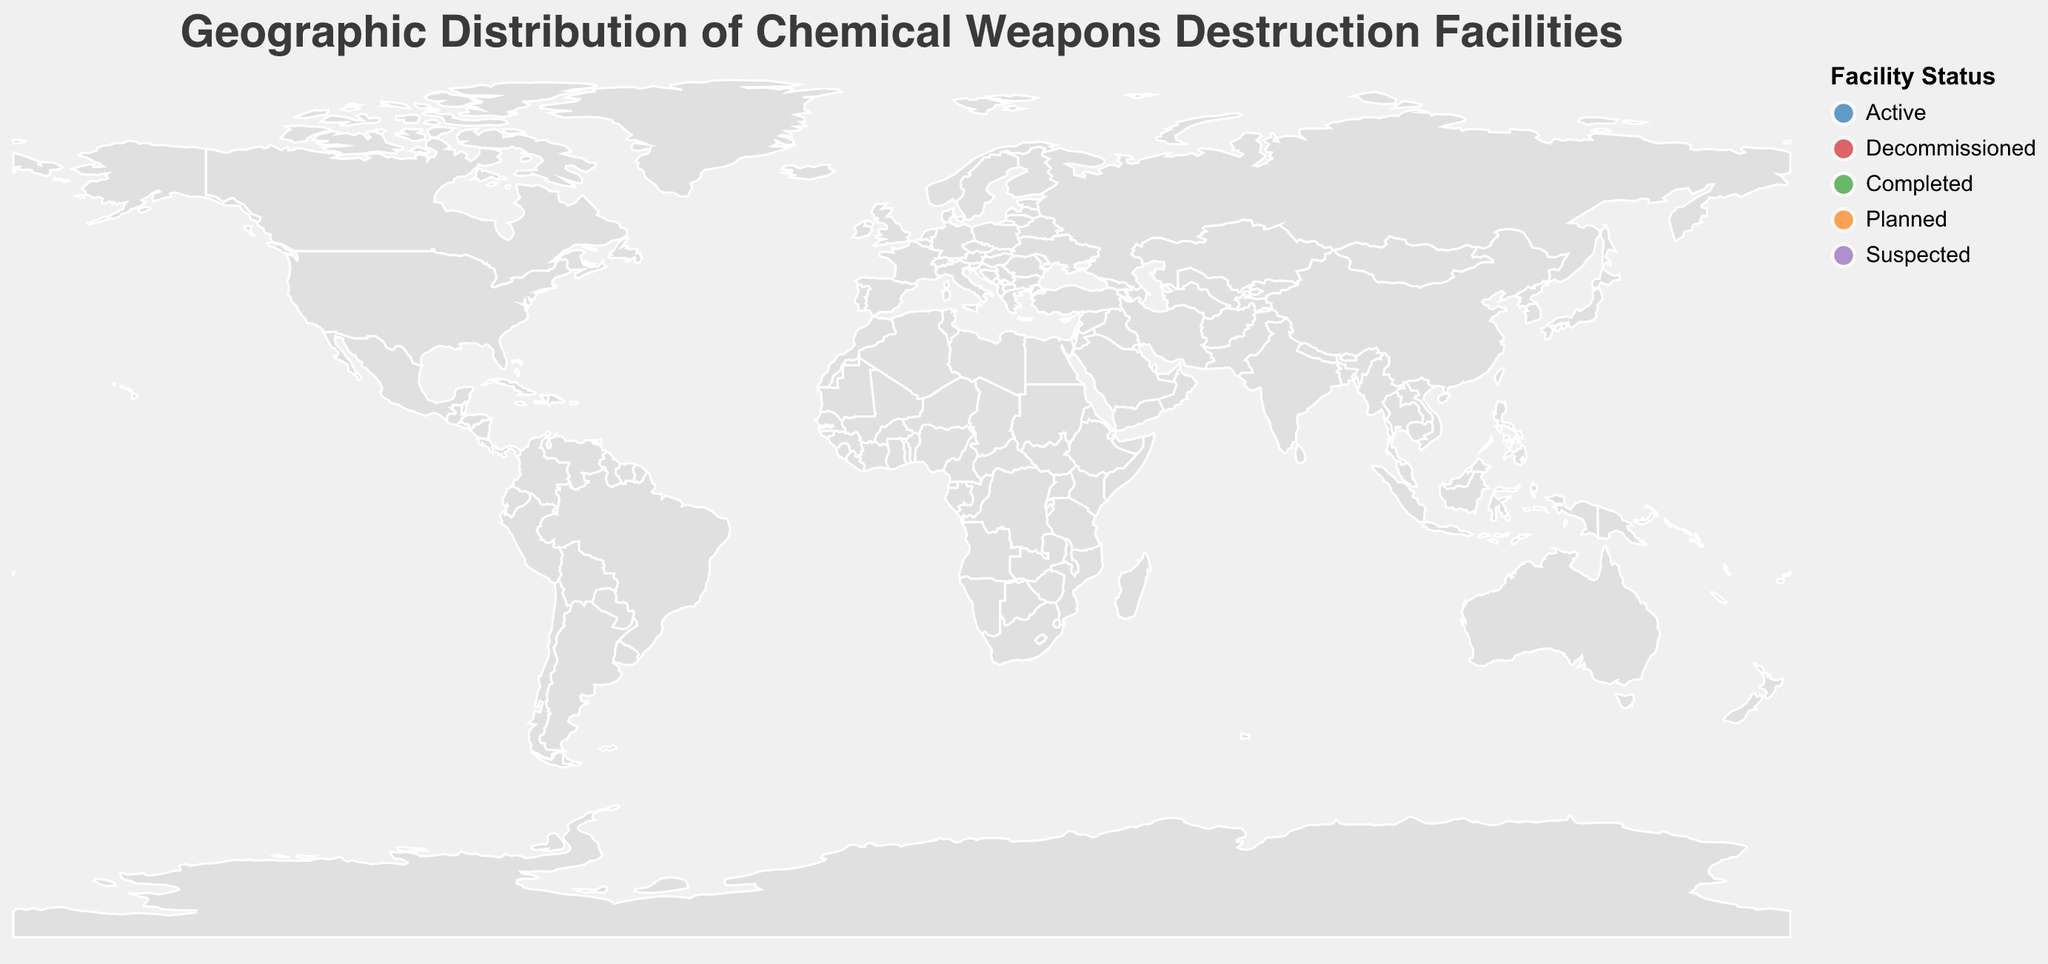Which country has the highest destruction capacity? The figure shows various destruction capacities for different facilities. Among all, the Shchuchye Chemical Weapons Destruction Facility in Russia has the highest capacity of 1100 units.
Answer: Russia How many facilities are listed as Active on the map? The figure uses different colors to denote the status of each facility. The "Active" status is marked in blue. We can count the blue circles and find that there are 3 active facilities: Blue Grass Chemical Agent-Destruction Pilot Plant, Hawthorne Army Depot, and Munster-Grohn GEKA Facility.
Answer: 3 What is the total destruction capacity of the facilities in the USA? There are three facilities in the USA: Blue Grass Chemical Agent-Destruction Pilot Plant with a capacity of 523, Anniston Chemical Agent Disposal Facility with 0, and Hawthorne Army Depot with a capacity of 45. Summing these capacities: 523 + 0 + 45 = 568.
Answer: 568 Which facility in the figure has the smallest destruction capacity and what is its status? The figure shows different destruction capacities represented by the size of the circles. The Dimona Facility in Israel has the smallest capacity of 18, and its status is "Suspected."
Answer: Dimona Facility, Suspected Compare the destruction capacities between the active facilities in Germany and Tunisia. Which one is higher and by how much? The Munster-Grohn GEKA Facility in Germany is active with a capacity of 36, while the Mornag Chemical Weapons Destruction Facility in Tunisia is planned with a capacity of 0. Thus, the German facility has a higher capacity by 36 units.
Answer: Germany by 36 Which continent shows the highest number of facilities, and how many are there? By visually scanning the geographic locations on the map, North America appears to have the highest number with three facilities (USA). Other continents such as Europe and Asia have fewer facilities.
Answer: North America, 3 How many facilities are in a status other than Active? By referring to the legend and counting the circles of colors other than blue, there are 5 such facilities: Rhydymwyn Valley Works (Decommissioned), Shchuchye Chemical Weapons Destruction Facility (Completed), Anniston Chemical Agent Disposal Facility (Completed), Mornag Chemical Weapons Destruction Facility (Planned), and Dimona Facility (Suspected).
Answer: 5 What is the title of the figure? The title is positioned at the top center of the figure and reads "Geographic Distribution of Chemical Weapons Destruction Facilities," written in Helvetica font with a size of 20.
Answer: Geographic Distribution of Chemical Weapons Destruction Facilities Which facility is located in Russia, and what is its status? The Shchuchye Chemical Weapons Destruction Facility located in Russia is marked on the figure, with a status of Completed.
Answer: Shchuchye Chemical Weapons Destruction Facility, Completed 